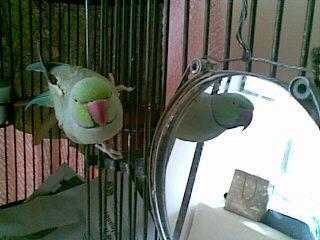How many cats are in the image?
Give a very brief answer. 0. How many birds are in the photo?
Give a very brief answer. 2. 